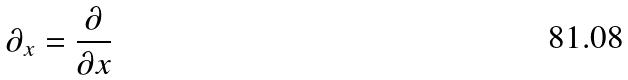<formula> <loc_0><loc_0><loc_500><loc_500>\partial _ { x } = \frac { \partial } { \partial x }</formula> 